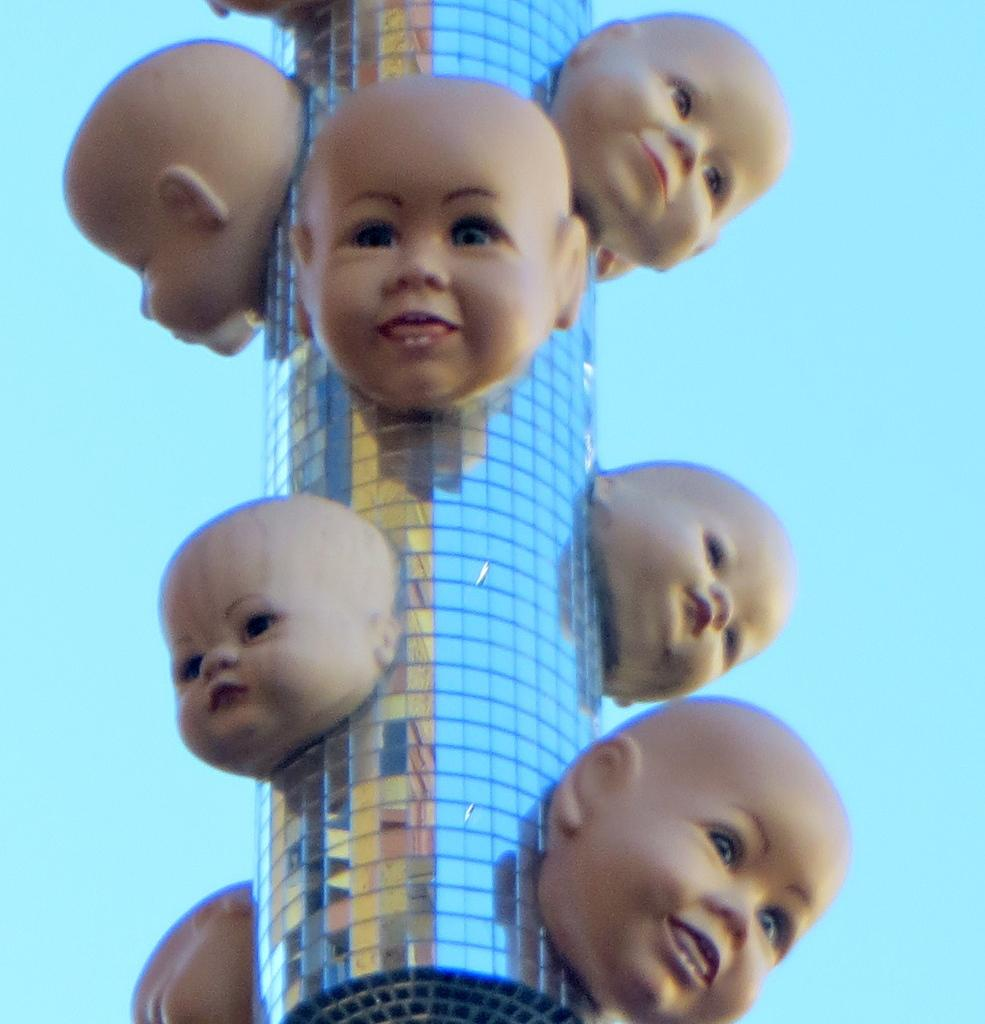What type of building is in the picture? There is a glass tower building in the picture. What is unique about the appearance of this building? Baby faces are attached to the building. How many quills can be seen attached to the building in the image? There are no quills present in the image; the building has baby faces attached to it. 